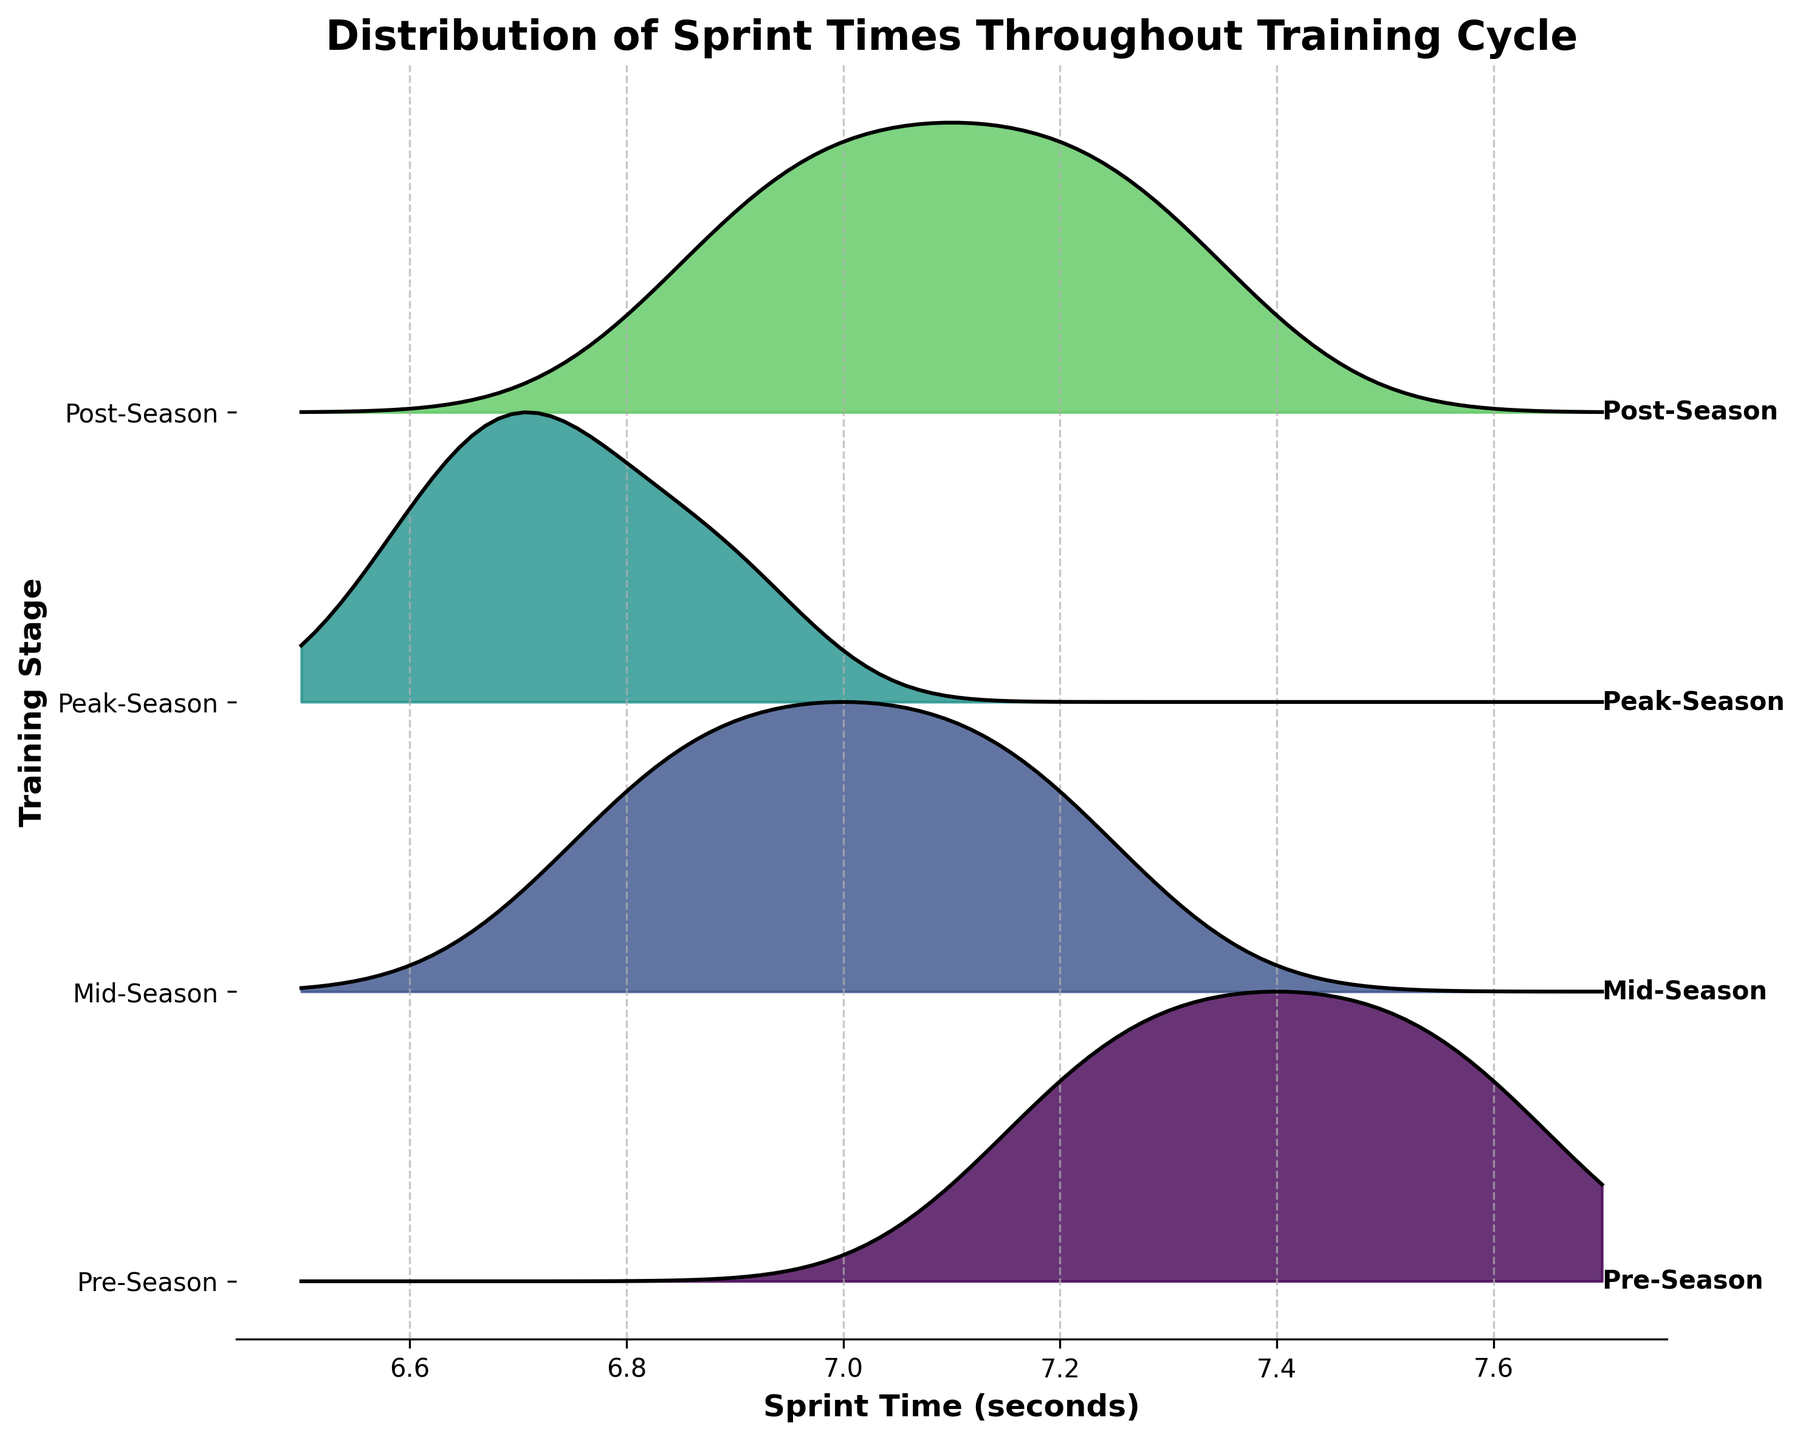What's the title of the figure? The title of the figure is displayed at the top and reads "Distribution of Sprint Times Throughout Training Cycle."
Answer: Distribution of Sprint Times Throughout Training Cycle Which training stage has the lowest average sprint time? We observe the peak of the ridgeline plot for each stage and note that the Peak-Season stage has the peaks shifted towards the lower sprint times. Thus, Peak-Season has the lowest average sprint time.
Answer: Peak-Season What is the range of sprint times displayed on the x-axis? By examining the x-axis, we see it ranges from 6.5 to 7.7 seconds.
Answer: 6.5 to 7.7 seconds Which stage shows the greatest variability in sprint times? By comparing the width of the distributions, we note that Pre-Season's distribution is broader than the others, indicating greater variability.
Answer: Pre-Season How does the sprint time distribution change from Pre-Season to Mid-Season? Comparing the Pre-Season and Mid-Season distributions, the Mid-Season distribution shifts slightly to the left, indicating faster sprint times, and becomes narrower, indicating reduced variability.
Answer: It shifts left and becomes narrower Is there a pattern to how sprint times change throughout the training cycle stages? By observing the distributions from Pre-Season to Peak-Season, we see a consistent trend of improving (faster) sprint times, followed by a slight regression in the Post-Season.
Answer: Faster to Peak-Season, then slight regression In which training stage does player sprint times show the least consistency? Stages with broader distributions indicate less consistency. Pre-Season, with its broader range, shows the least consistency in sprint times.
Answer: Pre-Season Which training stage has the highest peak near the 7.0 second mark? By examining the peaks of the distributions, Mid-Season has the most prominent peak near the 7.0-second mark on the x-axis.
Answer: Mid-Season 